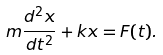<formula> <loc_0><loc_0><loc_500><loc_500>m { \frac { d ^ { 2 } x } { d t ^ { 2 } } } + k x = F ( t ) .</formula> 